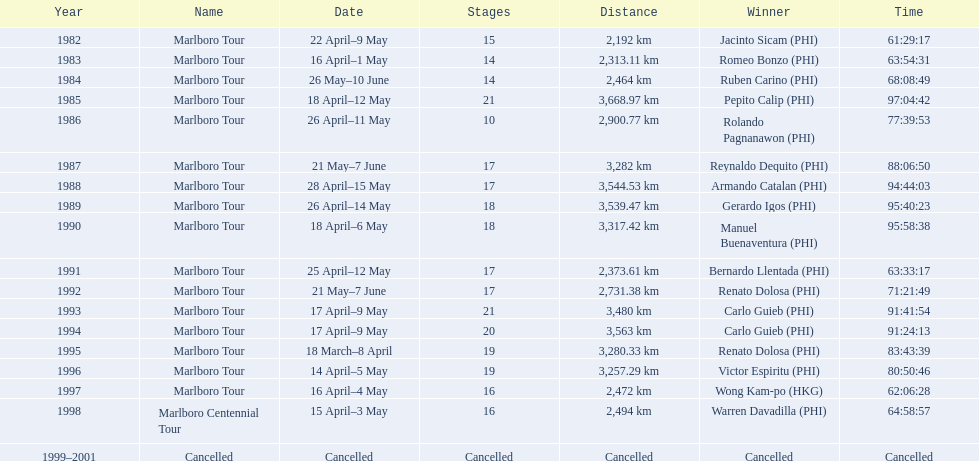What were the stage names during le tour de filipinas? Marlboro Tour, Marlboro Tour, Marlboro Tour, Marlboro Tour, Marlboro Tour, Marlboro Tour, Marlboro Tour, Marlboro Tour, Marlboro Tour, Marlboro Tour, Marlboro Tour, Marlboro Tour, Marlboro Tour, Marlboro Tour, Marlboro Tour, Marlboro Tour, Marlboro Centennial Tour, Cancelled. What were the registered distances for each marlboro tour? 2,192 km, 2,313.11 km, 2,464 km, 3,668.97 km, 2,900.77 km, 3,282 km, 3,544.53 km, 3,539.47 km, 3,317.42 km, 2,373.61 km, 2,731.38 km, 3,480 km, 3,563 km, 3,280.33 km, 3,257.29 km, 2,472 km. And out of those distances, which one was the farthest? 3,668.97 km. 